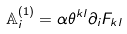<formula> <loc_0><loc_0><loc_500><loc_500>\mathbb { A } _ { i } ^ { ( 1 ) } = \alpha \theta ^ { k l } \partial _ { i } F _ { k l }</formula> 